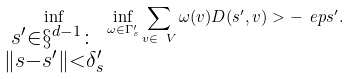Convert formula to latex. <formula><loc_0><loc_0><loc_500><loc_500>\inf _ { \substack { s ^ { \prime } \in \S ^ { d - 1 } \colon \\ \| s - s ^ { \prime } \| < \delta ^ { \prime } _ { s } } } \inf _ { \omega \in \Gamma ^ { \prime } _ { s } } \sum _ { v \in \ V } \omega ( v ) D ( s ^ { \prime } , v ) > - \ e p s ^ { \prime } .</formula> 